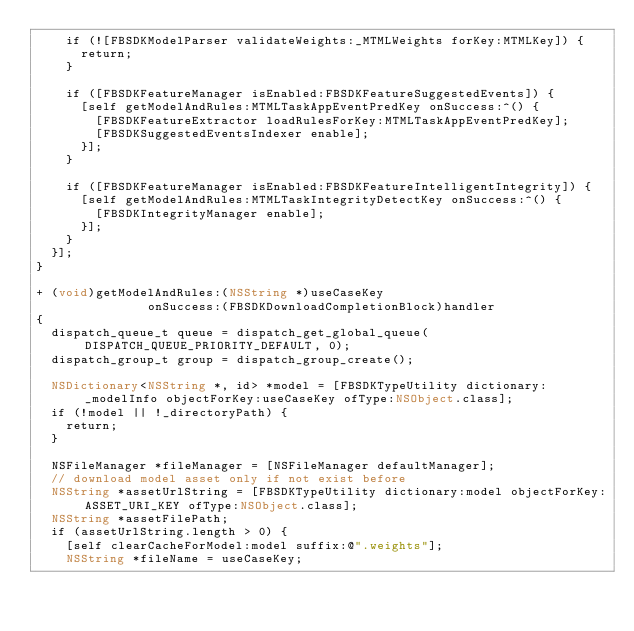Convert code to text. <code><loc_0><loc_0><loc_500><loc_500><_ObjectiveC_>    if (![FBSDKModelParser validateWeights:_MTMLWeights forKey:MTMLKey]) {
      return;
    }

    if ([FBSDKFeatureManager isEnabled:FBSDKFeatureSuggestedEvents]) {
      [self getModelAndRules:MTMLTaskAppEventPredKey onSuccess:^() {
        [FBSDKFeatureExtractor loadRulesForKey:MTMLTaskAppEventPredKey];
        [FBSDKSuggestedEventsIndexer enable];
      }];
    }

    if ([FBSDKFeatureManager isEnabled:FBSDKFeatureIntelligentIntegrity]) {
      [self getModelAndRules:MTMLTaskIntegrityDetectKey onSuccess:^() {
        [FBSDKIntegrityManager enable];
      }];
    }
  }];
}

+ (void)getModelAndRules:(NSString *)useCaseKey
               onSuccess:(FBSDKDownloadCompletionBlock)handler
{
  dispatch_queue_t queue = dispatch_get_global_queue(DISPATCH_QUEUE_PRIORITY_DEFAULT, 0);
  dispatch_group_t group = dispatch_group_create();

  NSDictionary<NSString *, id> *model = [FBSDKTypeUtility dictionary:_modelInfo objectForKey:useCaseKey ofType:NSObject.class];
  if (!model || !_directoryPath) {
    return;
  }

  NSFileManager *fileManager = [NSFileManager defaultManager];
  // download model asset only if not exist before
  NSString *assetUrlString = [FBSDKTypeUtility dictionary:model objectForKey:ASSET_URI_KEY ofType:NSObject.class];
  NSString *assetFilePath;
  if (assetUrlString.length > 0) {
    [self clearCacheForModel:model suffix:@".weights"];
    NSString *fileName = useCaseKey;</code> 